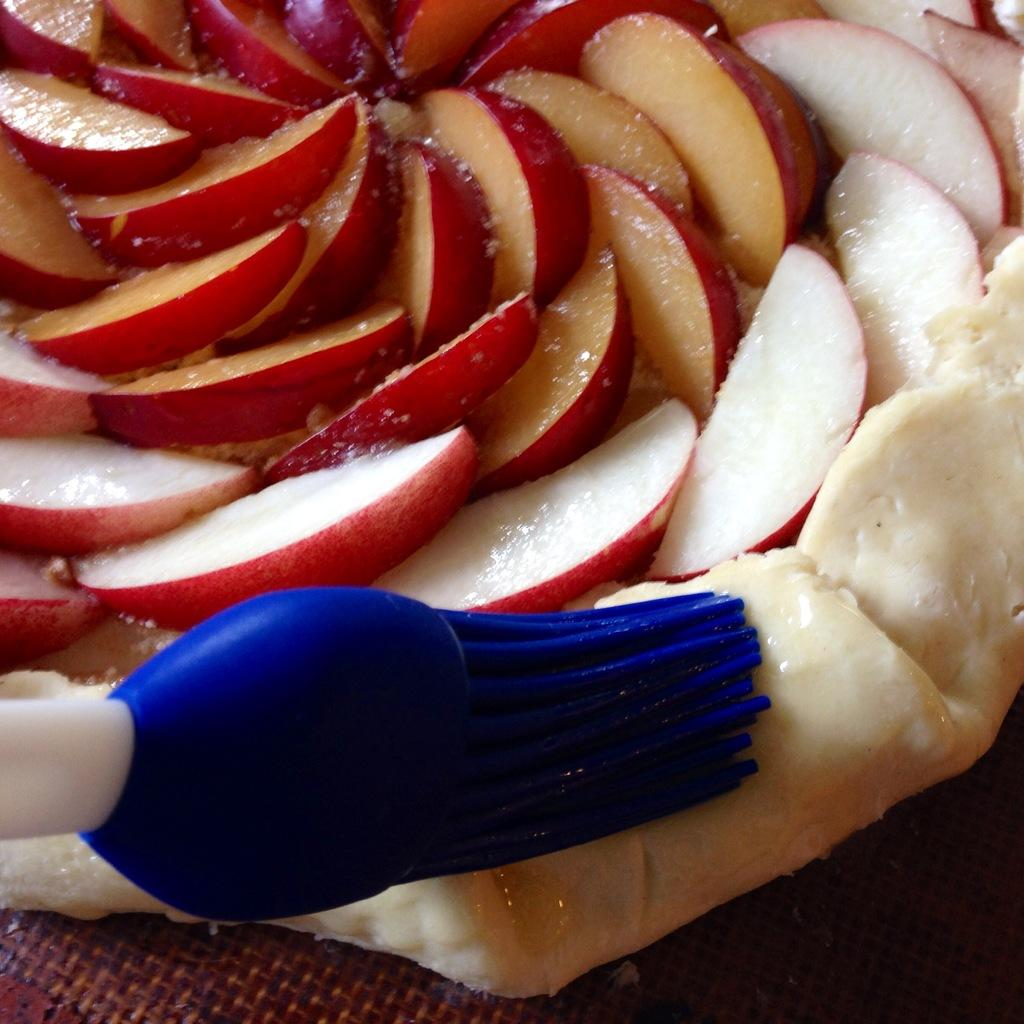What type of food can be seen in the image? There are apple slices in the image. Can you describe any other objects in the image besides the food? Yes, there is a brush in the image. What type of arch can be seen in the image? There is no arch present in the image. What material is the copper used for in the image? There is no copper present in the image. 